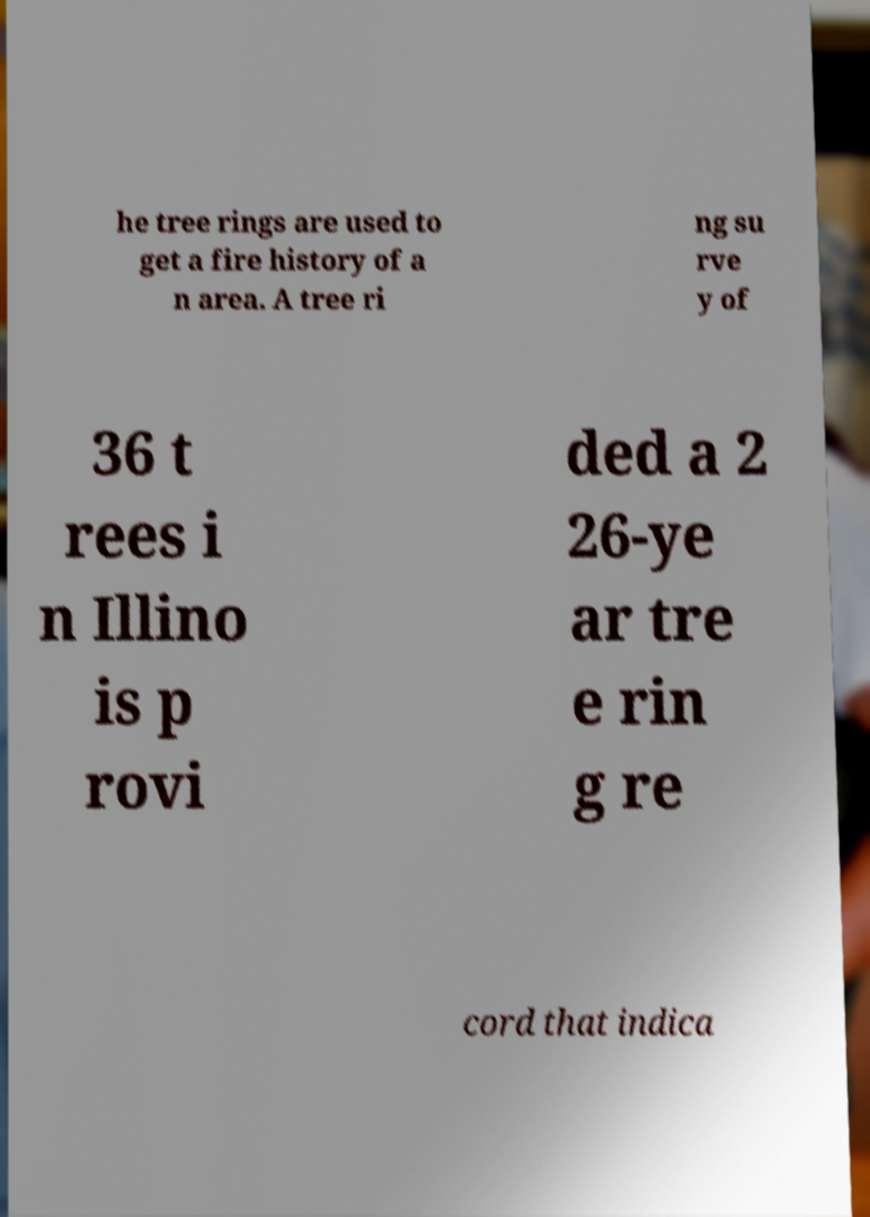Could you assist in decoding the text presented in this image and type it out clearly? he tree rings are used to get a fire history of a n area. A tree ri ng su rve y of 36 t rees i n Illino is p rovi ded a 2 26-ye ar tre e rin g re cord that indica 